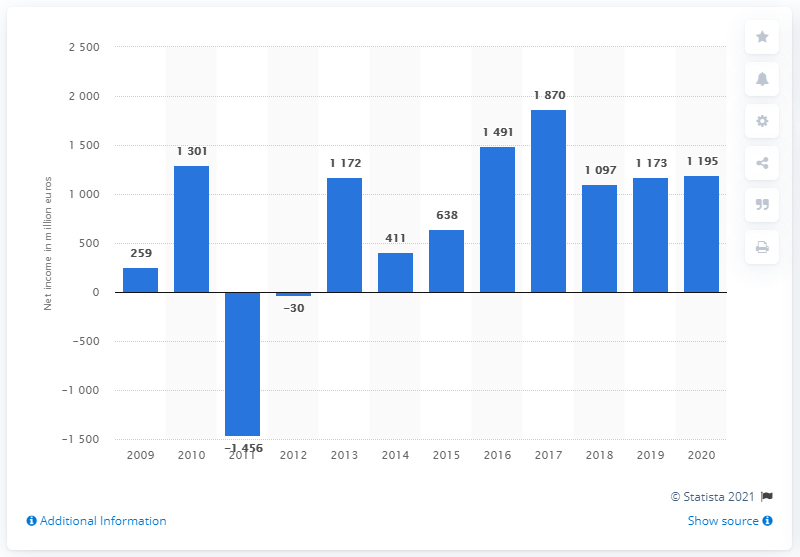Specify some key components in this picture. In 2020, the net income of Philips was 1195. 